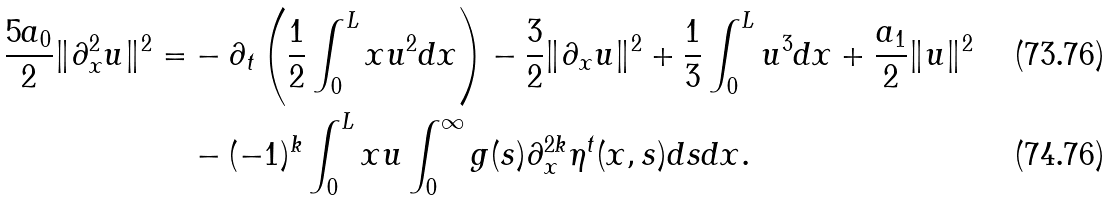Convert formula to latex. <formula><loc_0><loc_0><loc_500><loc_500>\frac { 5 a _ { 0 } } { 2 } \| \partial _ { x } ^ { 2 } u \| ^ { 2 } = & - \partial _ { t } \left ( \frac { 1 } { 2 } \int _ { 0 } ^ { L } x u ^ { 2 } d x \right ) - \frac { 3 } { 2 } \| \partial _ { x } u \| ^ { 2 } + \frac { 1 } { 3 } \int _ { 0 } ^ { L } u ^ { 3 } d x + \frac { a _ { 1 } } { 2 } \| u \| ^ { 2 } \\ & - ( - 1 ) ^ { k } \int _ { 0 } ^ { L } x u \int _ { 0 } ^ { \infty } g ( s ) \partial _ { x } ^ { 2 k } \eta ^ { t } ( x , s ) d s d x .</formula> 